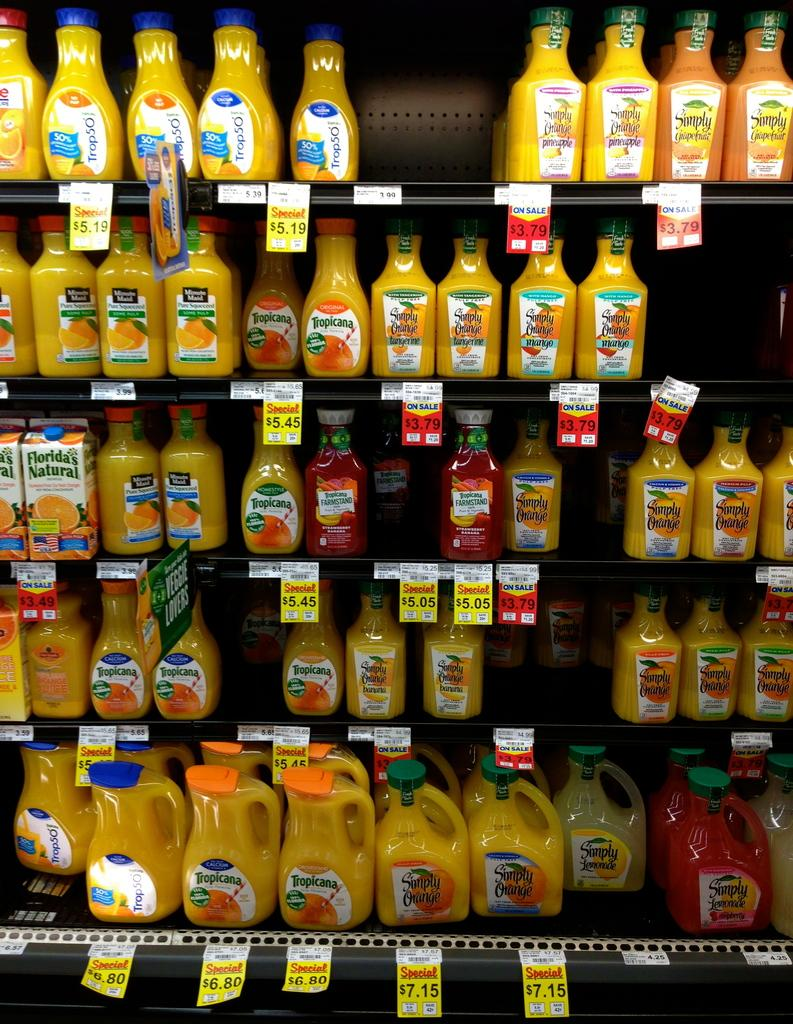What is present in the image that is used for holding items? There is a rack in the image. What type of items can be seen on the rack? There are bottles arranged in an order on the rack. What type of sugar is being used by the judge in the image? There is no judge or sugar present in the image; it only features a rack with bottles arranged on it. 